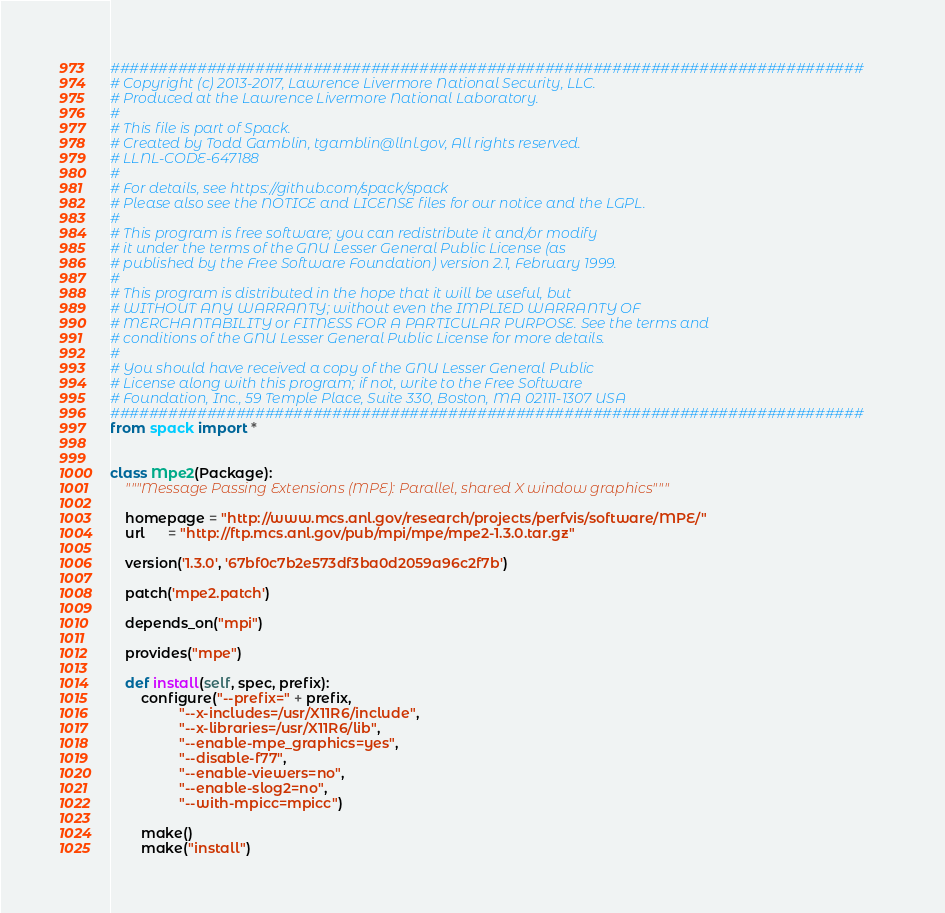<code> <loc_0><loc_0><loc_500><loc_500><_Python_>##############################################################################
# Copyright (c) 2013-2017, Lawrence Livermore National Security, LLC.
# Produced at the Lawrence Livermore National Laboratory.
#
# This file is part of Spack.
# Created by Todd Gamblin, tgamblin@llnl.gov, All rights reserved.
# LLNL-CODE-647188
#
# For details, see https://github.com/spack/spack
# Please also see the NOTICE and LICENSE files for our notice and the LGPL.
#
# This program is free software; you can redistribute it and/or modify
# it under the terms of the GNU Lesser General Public License (as
# published by the Free Software Foundation) version 2.1, February 1999.
#
# This program is distributed in the hope that it will be useful, but
# WITHOUT ANY WARRANTY; without even the IMPLIED WARRANTY OF
# MERCHANTABILITY or FITNESS FOR A PARTICULAR PURPOSE. See the terms and
# conditions of the GNU Lesser General Public License for more details.
#
# You should have received a copy of the GNU Lesser General Public
# License along with this program; if not, write to the Free Software
# Foundation, Inc., 59 Temple Place, Suite 330, Boston, MA 02111-1307 USA
##############################################################################
from spack import *


class Mpe2(Package):
    """Message Passing Extensions (MPE): Parallel, shared X window graphics"""

    homepage = "http://www.mcs.anl.gov/research/projects/perfvis/software/MPE/"
    url      = "http://ftp.mcs.anl.gov/pub/mpi/mpe/mpe2-1.3.0.tar.gz"

    version('1.3.0', '67bf0c7b2e573df3ba0d2059a96c2f7b')

    patch('mpe2.patch')

    depends_on("mpi")

    provides("mpe")

    def install(self, spec, prefix):
        configure("--prefix=" + prefix,
                  "--x-includes=/usr/X11R6/include",
                  "--x-libraries=/usr/X11R6/lib",
                  "--enable-mpe_graphics=yes",
                  "--disable-f77",
                  "--enable-viewers=no",
                  "--enable-slog2=no",
                  "--with-mpicc=mpicc")

        make()
        make("install")
</code> 